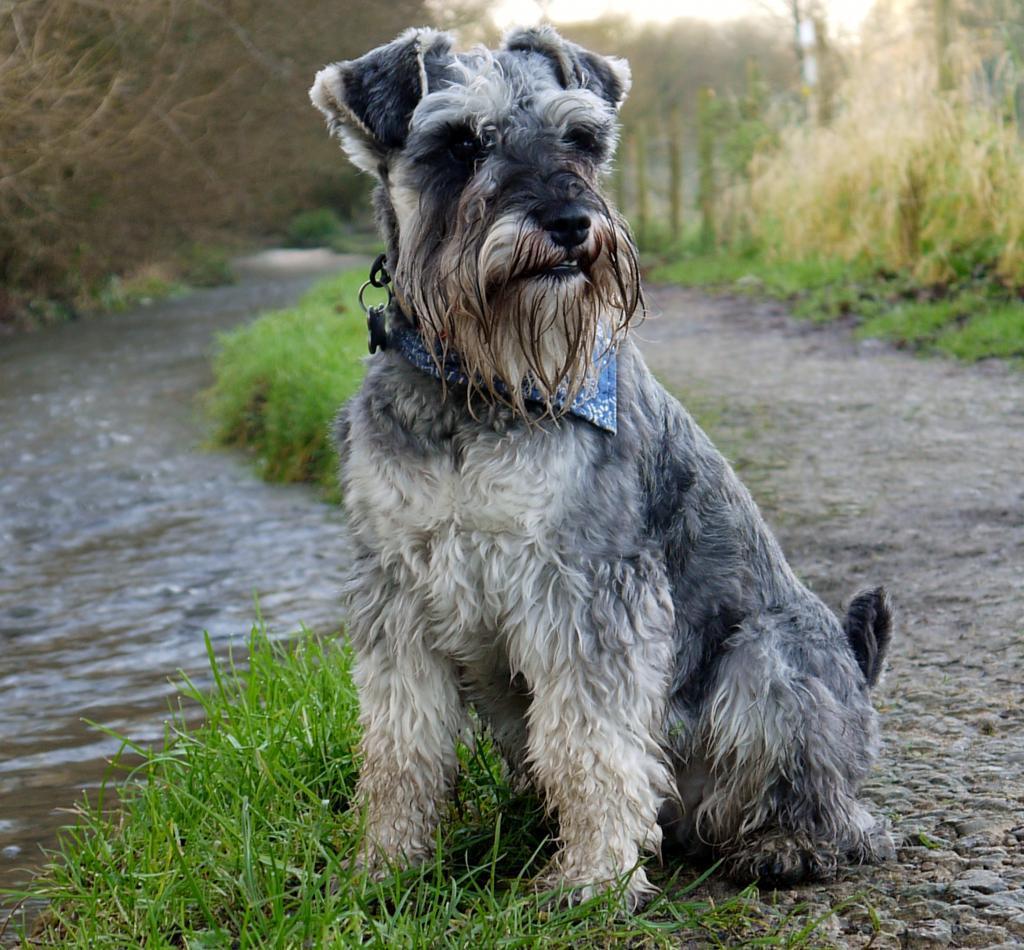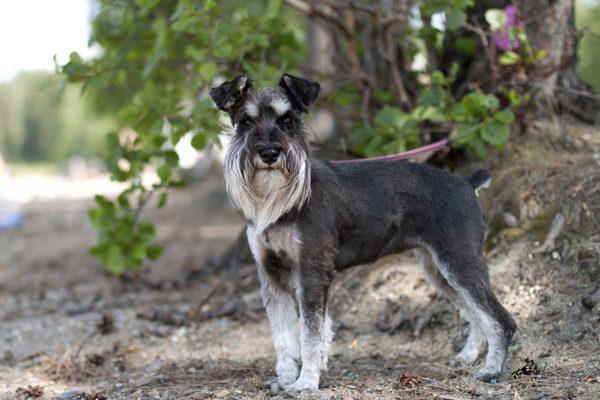The first image is the image on the left, the second image is the image on the right. Evaluate the accuracy of this statement regarding the images: "Schnauzer in the left image is wearing a kind of bandana around its neck.". Is it true? Answer yes or no. Yes. The first image is the image on the left, the second image is the image on the right. Given the left and right images, does the statement "the dog in the image on the right is wearing a collar" hold true? Answer yes or no. No. 